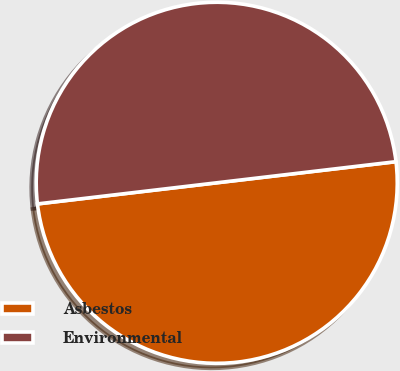<chart> <loc_0><loc_0><loc_500><loc_500><pie_chart><fcel>Asbestos<fcel>Environmental<nl><fcel>50.0%<fcel>50.0%<nl></chart> 